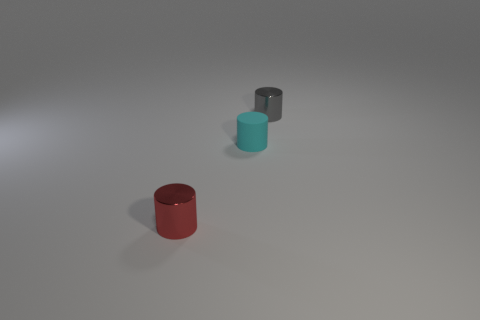Add 1 red shiny cylinders. How many objects exist? 4 Add 3 tiny cylinders. How many tiny cylinders exist? 6 Subtract 1 gray cylinders. How many objects are left? 2 Subtract all red metal things. Subtract all small cyan rubber cylinders. How many objects are left? 1 Add 2 small gray metal objects. How many small gray metal objects are left? 3 